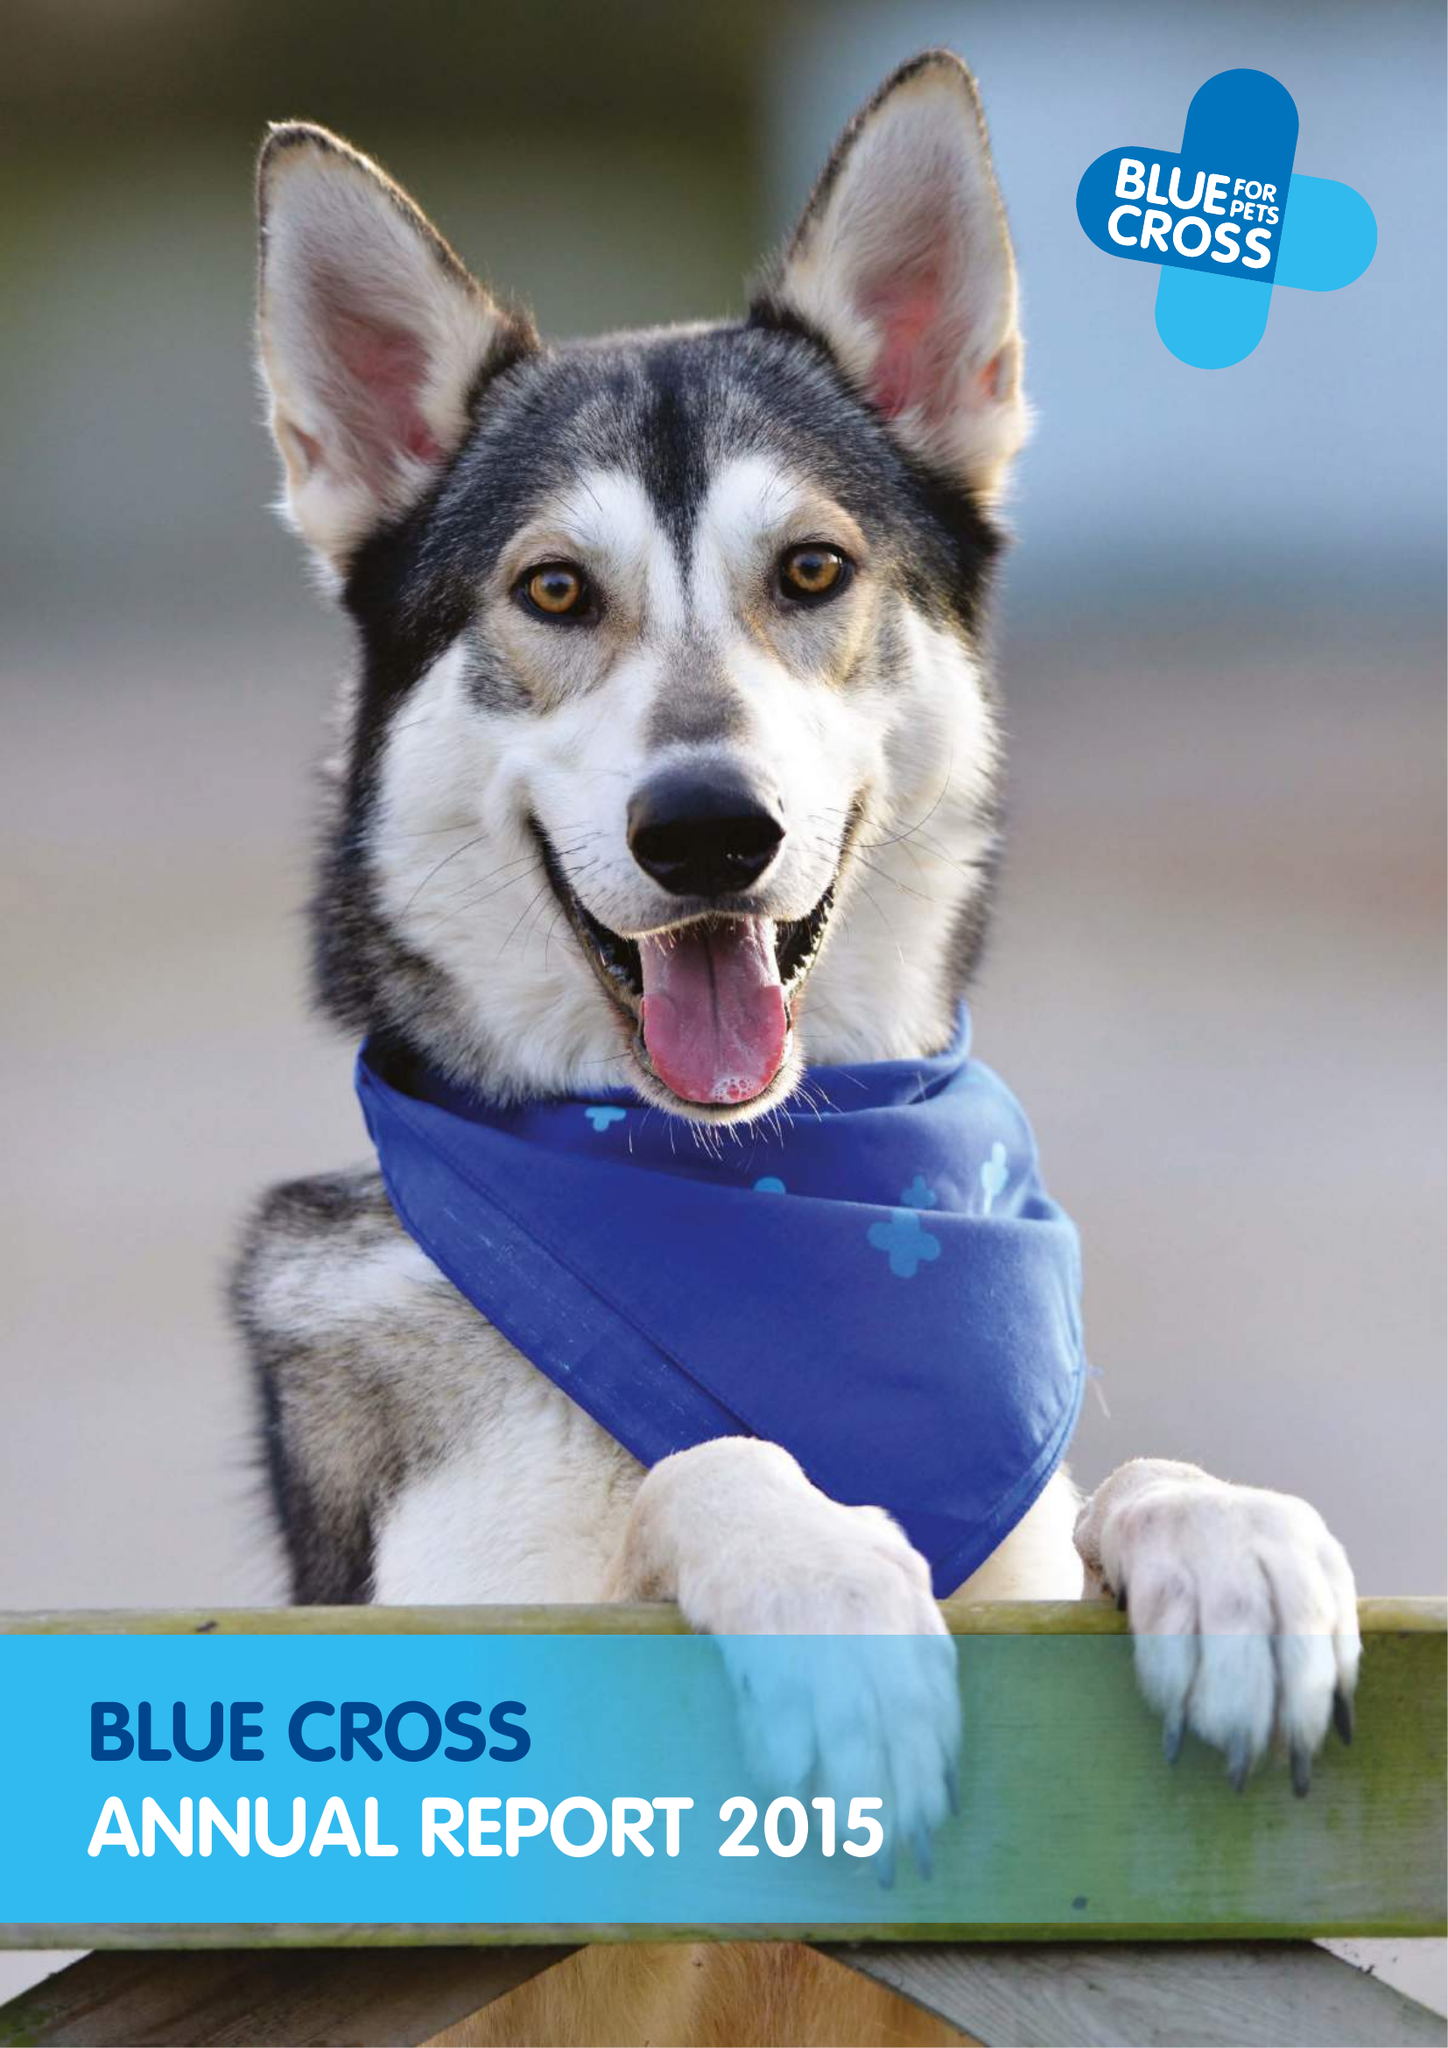What is the value for the address__post_town?
Answer the question using a single word or phrase. CARTERTON 